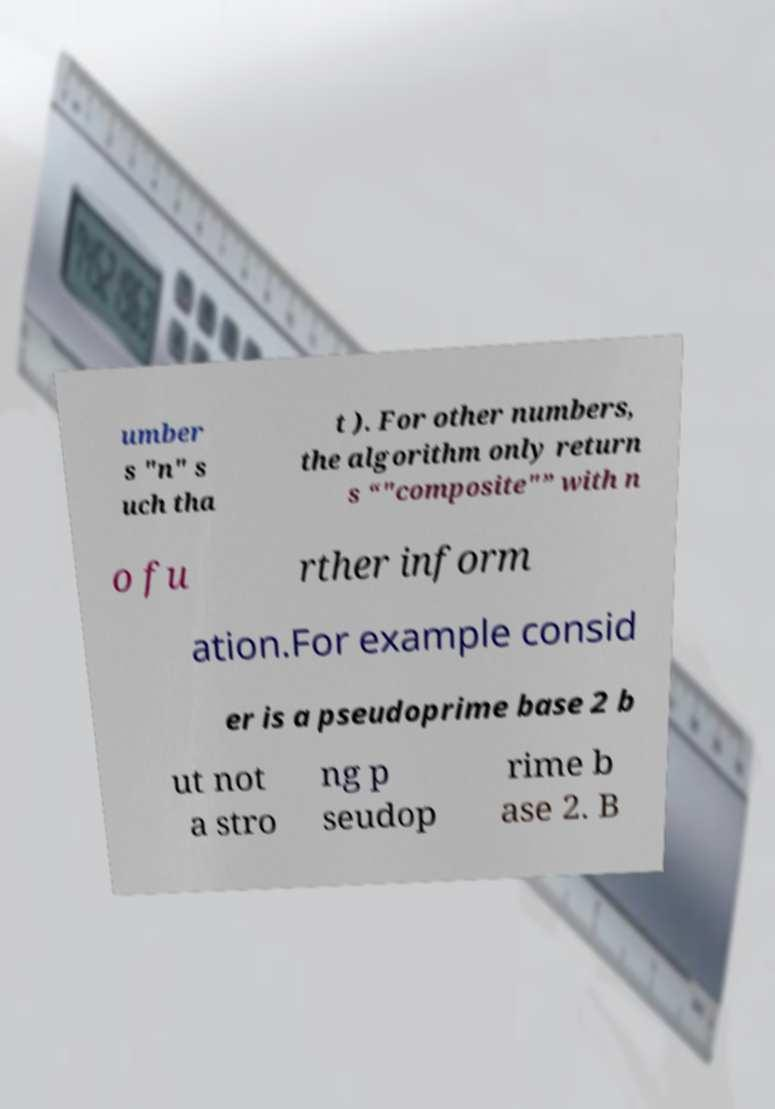I need the written content from this picture converted into text. Can you do that? umber s "n" s uch tha t ). For other numbers, the algorithm only return s “"composite"” with n o fu rther inform ation.For example consid er is a pseudoprime base 2 b ut not a stro ng p seudop rime b ase 2. B 